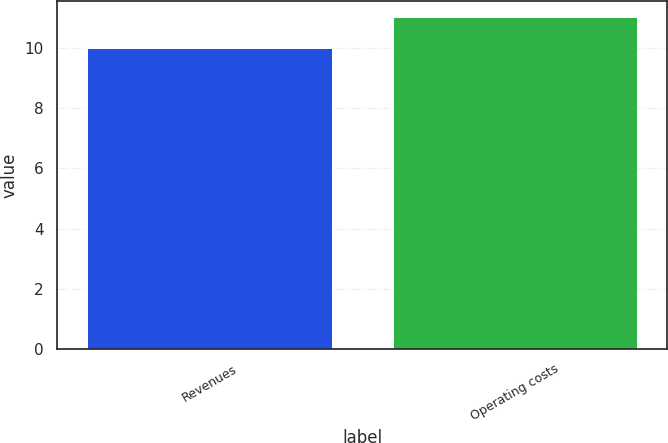<chart> <loc_0><loc_0><loc_500><loc_500><bar_chart><fcel>Revenues<fcel>Operating costs<nl><fcel>10<fcel>11<nl></chart> 